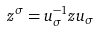<formula> <loc_0><loc_0><loc_500><loc_500>z ^ { \sigma } = u _ { \sigma } ^ { - 1 } z u _ { \sigma }</formula> 